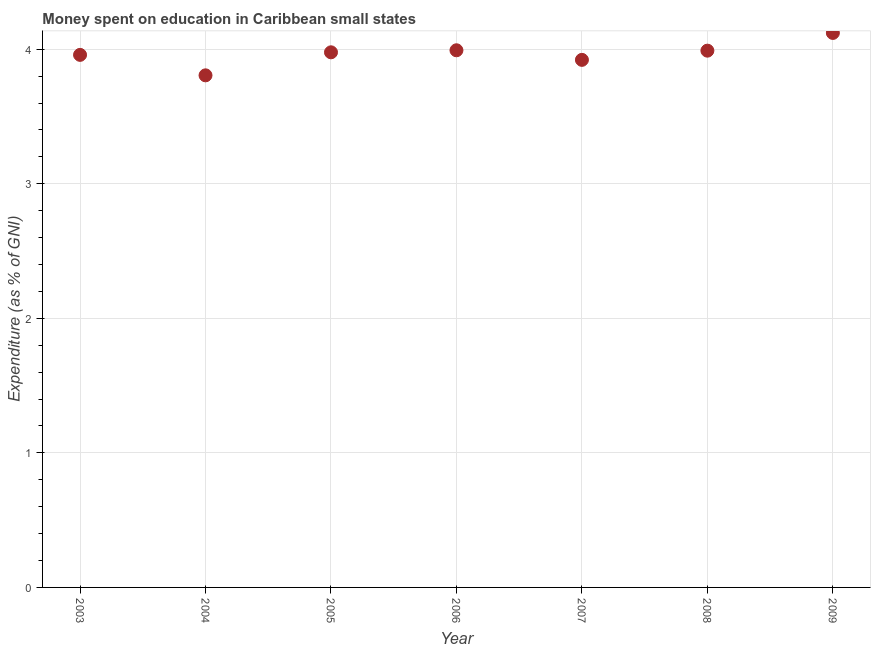What is the expenditure on education in 2007?
Offer a terse response. 3.92. Across all years, what is the maximum expenditure on education?
Your answer should be very brief. 4.12. Across all years, what is the minimum expenditure on education?
Your response must be concise. 3.81. In which year was the expenditure on education maximum?
Provide a short and direct response. 2009. In which year was the expenditure on education minimum?
Make the answer very short. 2004. What is the sum of the expenditure on education?
Provide a short and direct response. 27.77. What is the difference between the expenditure on education in 2003 and 2005?
Ensure brevity in your answer.  -0.02. What is the average expenditure on education per year?
Ensure brevity in your answer.  3.97. What is the median expenditure on education?
Provide a short and direct response. 3.98. Do a majority of the years between 2009 and 2004 (inclusive) have expenditure on education greater than 0.6000000000000001 %?
Provide a short and direct response. Yes. What is the ratio of the expenditure on education in 2005 to that in 2009?
Your response must be concise. 0.97. Is the difference between the expenditure on education in 2006 and 2007 greater than the difference between any two years?
Provide a succinct answer. No. What is the difference between the highest and the second highest expenditure on education?
Offer a terse response. 0.13. Is the sum of the expenditure on education in 2005 and 2009 greater than the maximum expenditure on education across all years?
Offer a very short reply. Yes. What is the difference between the highest and the lowest expenditure on education?
Give a very brief answer. 0.32. How many dotlines are there?
Your answer should be very brief. 1. How many years are there in the graph?
Your answer should be compact. 7. What is the difference between two consecutive major ticks on the Y-axis?
Provide a succinct answer. 1. Are the values on the major ticks of Y-axis written in scientific E-notation?
Your answer should be very brief. No. Does the graph contain any zero values?
Offer a very short reply. No. What is the title of the graph?
Your answer should be very brief. Money spent on education in Caribbean small states. What is the label or title of the X-axis?
Offer a terse response. Year. What is the label or title of the Y-axis?
Ensure brevity in your answer.  Expenditure (as % of GNI). What is the Expenditure (as % of GNI) in 2003?
Provide a short and direct response. 3.96. What is the Expenditure (as % of GNI) in 2004?
Your answer should be very brief. 3.81. What is the Expenditure (as % of GNI) in 2005?
Keep it short and to the point. 3.98. What is the Expenditure (as % of GNI) in 2006?
Keep it short and to the point. 3.99. What is the Expenditure (as % of GNI) in 2007?
Make the answer very short. 3.92. What is the Expenditure (as % of GNI) in 2008?
Your answer should be very brief. 3.99. What is the Expenditure (as % of GNI) in 2009?
Offer a terse response. 4.12. What is the difference between the Expenditure (as % of GNI) in 2003 and 2004?
Offer a terse response. 0.15. What is the difference between the Expenditure (as % of GNI) in 2003 and 2005?
Your answer should be very brief. -0.02. What is the difference between the Expenditure (as % of GNI) in 2003 and 2006?
Provide a short and direct response. -0.03. What is the difference between the Expenditure (as % of GNI) in 2003 and 2007?
Keep it short and to the point. 0.04. What is the difference between the Expenditure (as % of GNI) in 2003 and 2008?
Keep it short and to the point. -0.03. What is the difference between the Expenditure (as % of GNI) in 2003 and 2009?
Offer a very short reply. -0.16. What is the difference between the Expenditure (as % of GNI) in 2004 and 2005?
Your answer should be very brief. -0.17. What is the difference between the Expenditure (as % of GNI) in 2004 and 2006?
Your response must be concise. -0.19. What is the difference between the Expenditure (as % of GNI) in 2004 and 2007?
Offer a very short reply. -0.12. What is the difference between the Expenditure (as % of GNI) in 2004 and 2008?
Offer a terse response. -0.18. What is the difference between the Expenditure (as % of GNI) in 2004 and 2009?
Your answer should be compact. -0.32. What is the difference between the Expenditure (as % of GNI) in 2005 and 2006?
Ensure brevity in your answer.  -0.02. What is the difference between the Expenditure (as % of GNI) in 2005 and 2007?
Give a very brief answer. 0.06. What is the difference between the Expenditure (as % of GNI) in 2005 and 2008?
Keep it short and to the point. -0.01. What is the difference between the Expenditure (as % of GNI) in 2005 and 2009?
Ensure brevity in your answer.  -0.14. What is the difference between the Expenditure (as % of GNI) in 2006 and 2007?
Offer a very short reply. 0.07. What is the difference between the Expenditure (as % of GNI) in 2006 and 2008?
Your answer should be compact. 0. What is the difference between the Expenditure (as % of GNI) in 2006 and 2009?
Provide a succinct answer. -0.13. What is the difference between the Expenditure (as % of GNI) in 2007 and 2008?
Keep it short and to the point. -0.07. What is the difference between the Expenditure (as % of GNI) in 2007 and 2009?
Your answer should be very brief. -0.2. What is the difference between the Expenditure (as % of GNI) in 2008 and 2009?
Provide a short and direct response. -0.13. What is the ratio of the Expenditure (as % of GNI) in 2003 to that in 2009?
Your answer should be compact. 0.96. What is the ratio of the Expenditure (as % of GNI) in 2004 to that in 2006?
Offer a very short reply. 0.95. What is the ratio of the Expenditure (as % of GNI) in 2004 to that in 2008?
Offer a terse response. 0.95. What is the ratio of the Expenditure (as % of GNI) in 2004 to that in 2009?
Offer a terse response. 0.92. What is the ratio of the Expenditure (as % of GNI) in 2005 to that in 2006?
Provide a succinct answer. 1. What is the ratio of the Expenditure (as % of GNI) in 2005 to that in 2007?
Your answer should be compact. 1.01. What is the ratio of the Expenditure (as % of GNI) in 2005 to that in 2009?
Provide a short and direct response. 0.96. What is the ratio of the Expenditure (as % of GNI) in 2006 to that in 2007?
Keep it short and to the point. 1.02. What is the ratio of the Expenditure (as % of GNI) in 2007 to that in 2009?
Your response must be concise. 0.95. 